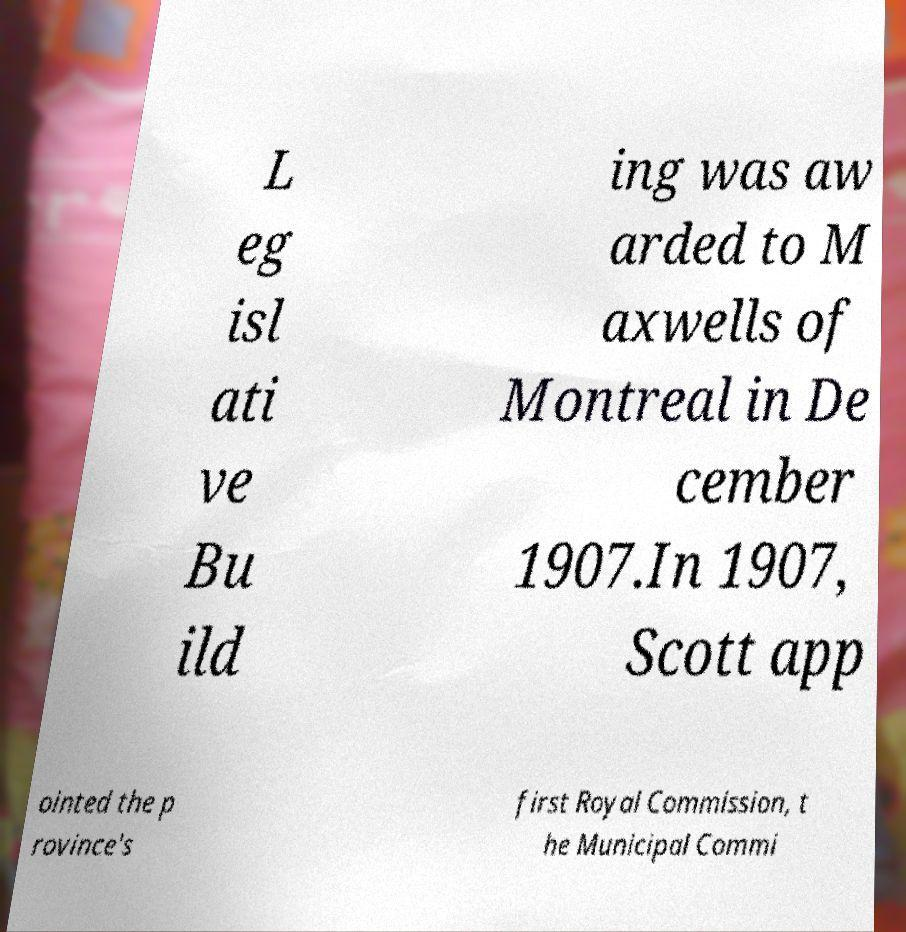There's text embedded in this image that I need extracted. Can you transcribe it verbatim? L eg isl ati ve Bu ild ing was aw arded to M axwells of Montreal in De cember 1907.In 1907, Scott app ointed the p rovince's first Royal Commission, t he Municipal Commi 